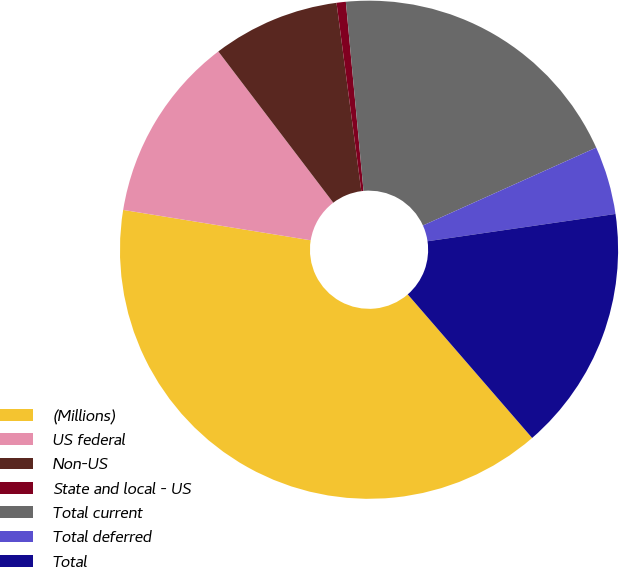Convert chart. <chart><loc_0><loc_0><loc_500><loc_500><pie_chart><fcel>(Millions)<fcel>US federal<fcel>Non-US<fcel>State and local - US<fcel>Total current<fcel>Total deferred<fcel>Total<nl><fcel>38.92%<fcel>12.1%<fcel>8.26%<fcel>0.6%<fcel>19.76%<fcel>4.43%<fcel>15.93%<nl></chart> 